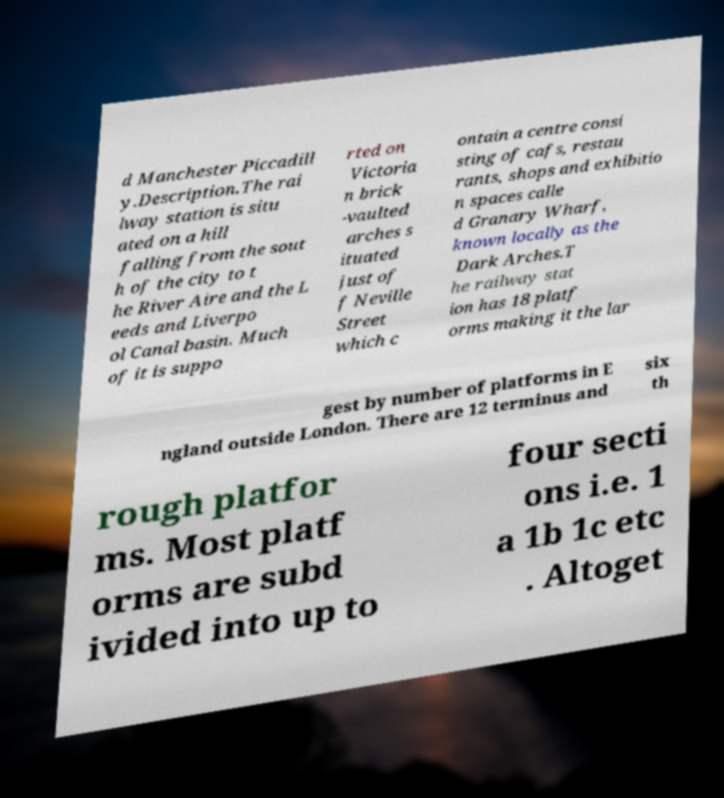Please identify and transcribe the text found in this image. d Manchester Piccadill y.Description.The rai lway station is situ ated on a hill falling from the sout h of the city to t he River Aire and the L eeds and Liverpo ol Canal basin. Much of it is suppo rted on Victoria n brick -vaulted arches s ituated just of f Neville Street which c ontain a centre consi sting of cafs, restau rants, shops and exhibitio n spaces calle d Granary Wharf, known locally as the Dark Arches.T he railway stat ion has 18 platf orms making it the lar gest by number of platforms in E ngland outside London. There are 12 terminus and six th rough platfor ms. Most platf orms are subd ivided into up to four secti ons i.e. 1 a 1b 1c etc . Altoget 